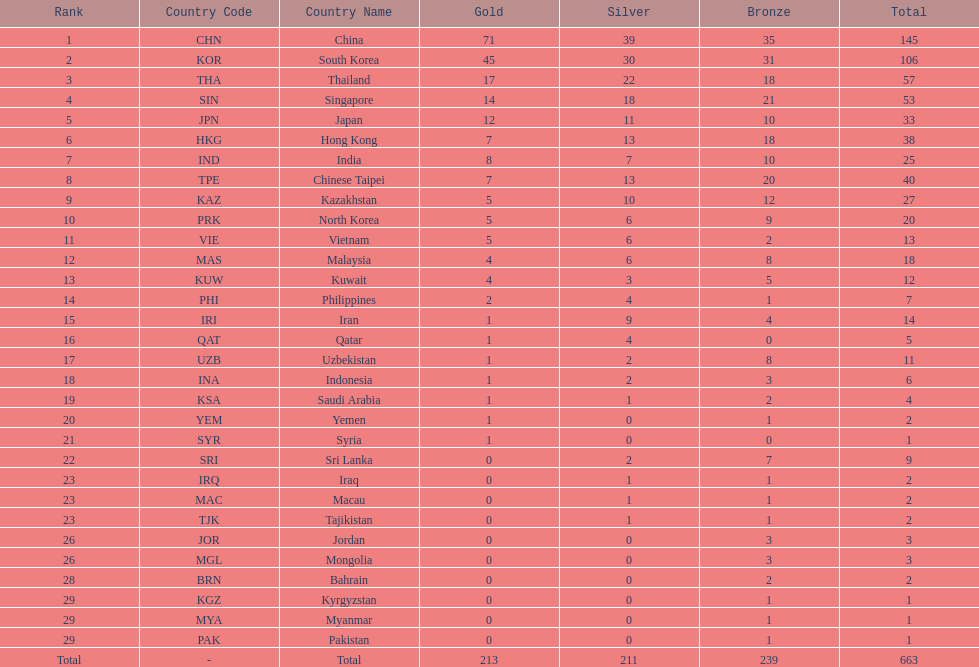How many more gold medals must qatar win before they can earn 12 gold medals? 11. 